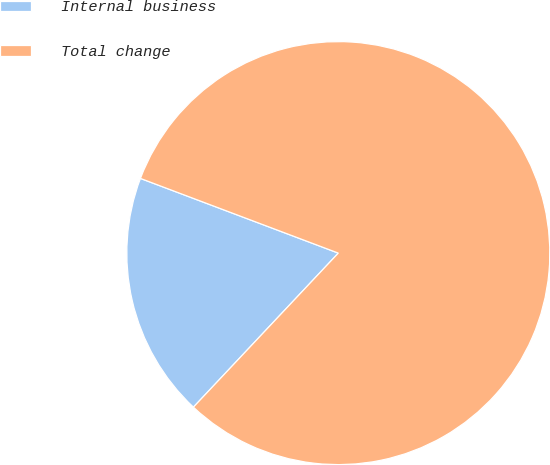Convert chart to OTSL. <chart><loc_0><loc_0><loc_500><loc_500><pie_chart><fcel>Internal business<fcel>Total change<nl><fcel>18.73%<fcel>81.27%<nl></chart> 